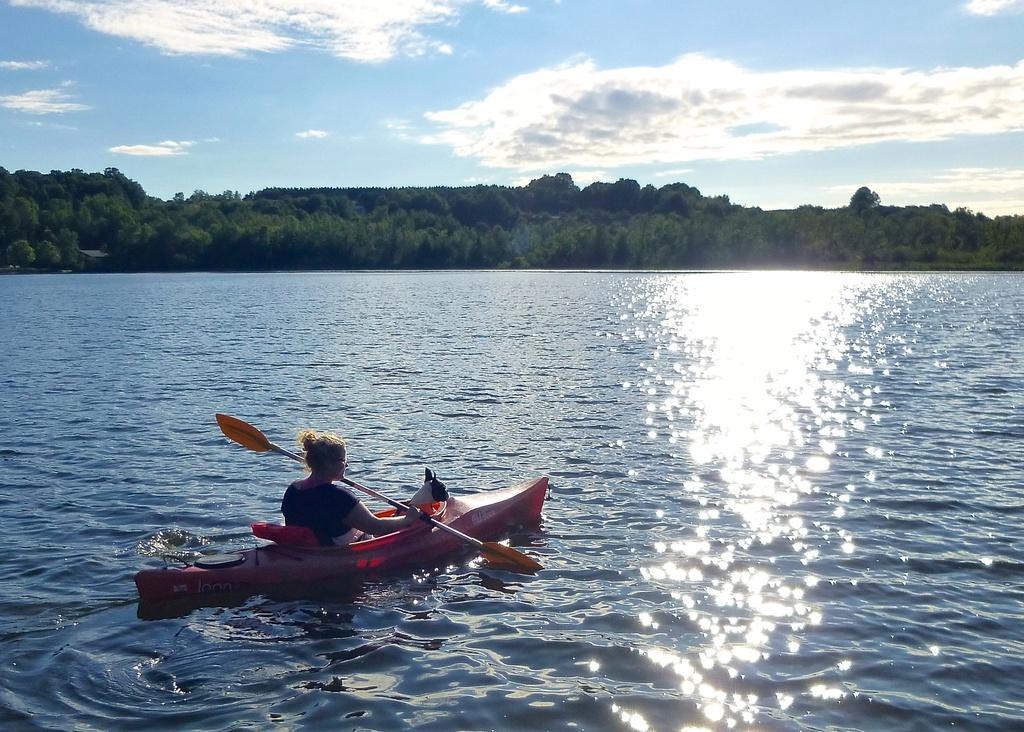In one or two sentences, can you explain what this image depicts? There is water. Also there is a woman sitting on a boat and rowing the paddle. There is an animal in the boat. In the background there are trees and sky. 